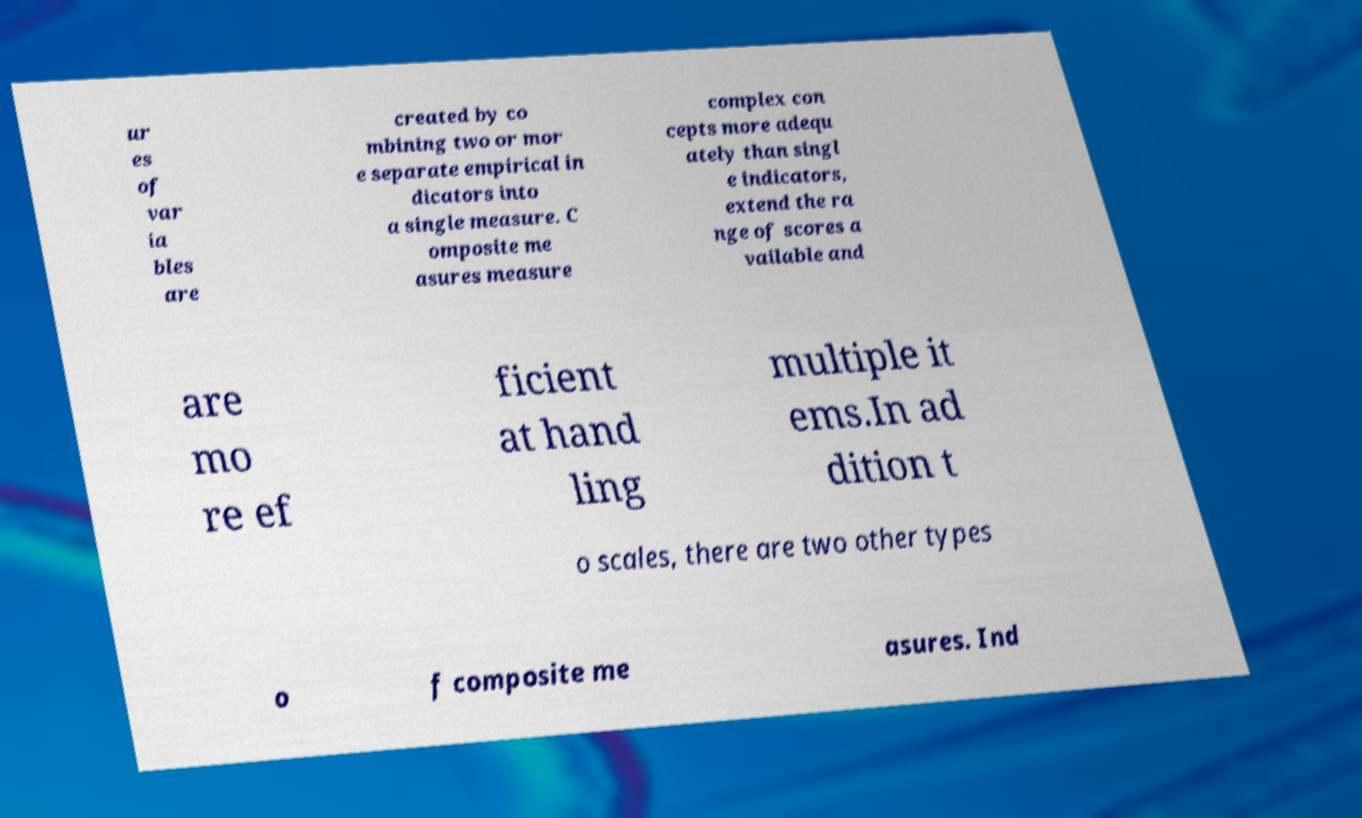I need the written content from this picture converted into text. Can you do that? ur es of var ia bles are created by co mbining two or mor e separate empirical in dicators into a single measure. C omposite me asures measure complex con cepts more adequ ately than singl e indicators, extend the ra nge of scores a vailable and are mo re ef ficient at hand ling multiple it ems.In ad dition t o scales, there are two other types o f composite me asures. Ind 